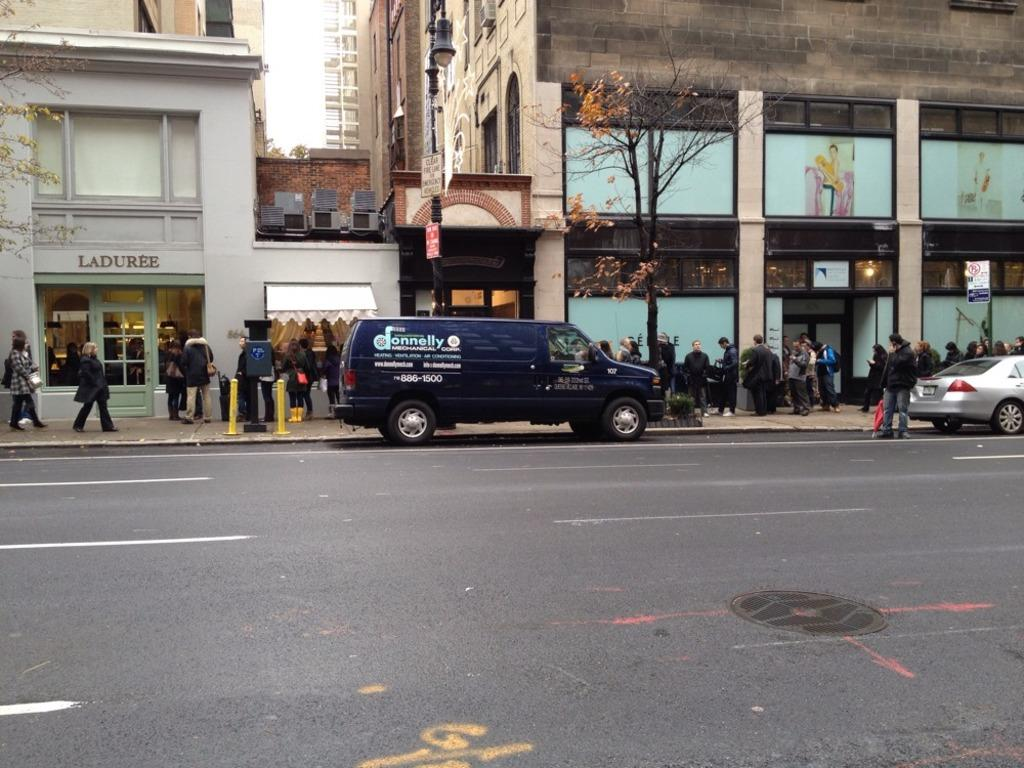<image>
Relay a brief, clear account of the picture shown. A van parked in front of a curb with Donnelly Mechanical written on the side. 